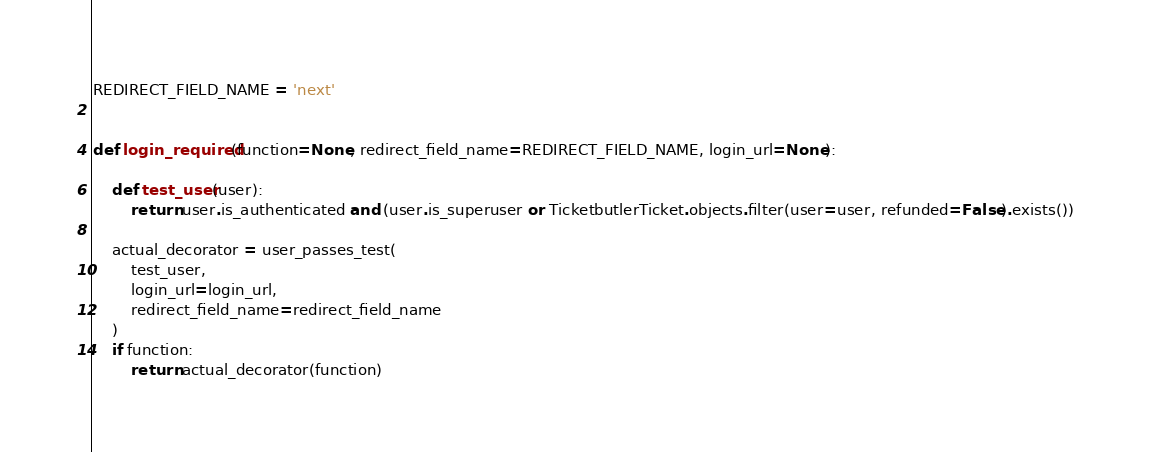<code> <loc_0><loc_0><loc_500><loc_500><_Python_>REDIRECT_FIELD_NAME = 'next'


def login_required(function=None, redirect_field_name=REDIRECT_FIELD_NAME, login_url=None):

    def test_user(user):
        return user.is_authenticated and (user.is_superuser or TicketbutlerTicket.objects.filter(user=user, refunded=False).exists())

    actual_decorator = user_passes_test(
        test_user,
        login_url=login_url,
        redirect_field_name=redirect_field_name
    )
    if function:
        return actual_decorator(function)
</code> 